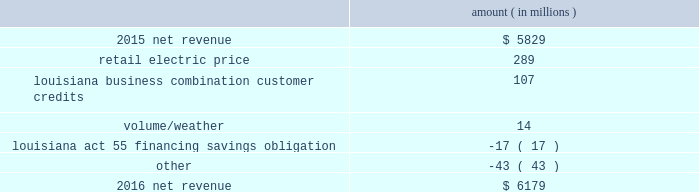Entergy corporation and subsidiaries management 2019s financial discussion and analysis palisades plants and related assets to their fair values .
See note 14 to the financial statements for further discussion of the impairment and related charges .
As a result of the entergy louisiana and entergy gulf states louisiana business combination , results of operations for 2015 also include two items that occurred in october 2015 : 1 ) a deferred tax asset and resulting net increase in tax basis of approximately $ 334 million and 2 ) a regulatory liability of $ 107 million ( $ 66 million net-of-tax ) as a result of customer credits to be realized by electric customers of entergy louisiana , consistent with the terms of the stipulated settlement in the business combination proceeding .
See note 2 to the financial statements for further discussion of the business combination and customer credits .
Results of operations for 2015 also include the sale in december 2015 of the 583 mw rhode island state energy center for a realized gain of $ 154 million ( $ 100 million net-of-tax ) on the sale and the $ 77 million ( $ 47 million net-of-tax ) write-off and regulatory charges to recognize that a portion of the assets associated with the waterford 3 replacement steam generator project is no longer probable of recovery .
See note 14 to the financial statements for further discussion of the rhode island state energy center sale .
See note 2 to the financial statements for further discussion of the waterford 3 write-off .
Net revenue utility following is an analysis of the change in net revenue comparing 2016 to 2015 .
Amount ( in millions ) .
The retail electric price variance is primarily due to : 2022 an increase in base rates at entergy arkansas , as approved by the apsc .
The new rates were effective february 24 , 2016 and began billing with the first billing cycle of april 2016 .
The increase includes an interim base rate adjustment surcharge , effective with the first billing cycle of april 2016 , to recover the incremental revenue requirement for the period february 24 , 2016 through march 31 , 2016 .
A significant portion of the increase is related to the purchase of power block 2 of the union power station ; 2022 an increase in the purchased power and capacity acquisition cost recovery rider for entergy new orleans , as approved by the city council , effective with the first billing cycle of march 2016 , primarily related to the purchase of power block 1 of the union power station ; 2022 an increase in formula rate plan revenues for entergy louisiana , implemented with the first billing cycle of march 2016 , to collect the estimated first-year revenue requirement related to the purchase of power blocks 3 and 4 of the union power station ; and 2022 an increase in revenues at entergy mississippi , as approved by the mpsc , effective with the first billing cycle of july 2016 , and an increase in revenues collected through the storm damage rider .
See note 2 to the financial statements for further discussion of the rate proceedings .
See note 14 to the financial statements for discussion of the union power station purchase .
The louisiana business combination customer credits variance is due to a regulatory liability of $ 107 million recorded by entergy in october 2015 as a result of the entergy gulf states louisiana and entergy louisiana business .
What is the sale in december 2015 of the 583 mw rhode island state energy center for a realized gain as a percentage of net revenue in 2015? 
Computations: (154 / 5829)
Answer: 0.02642. 